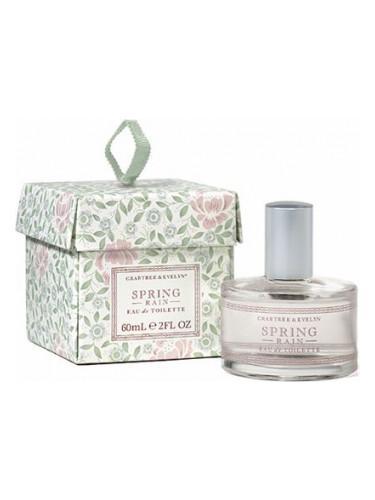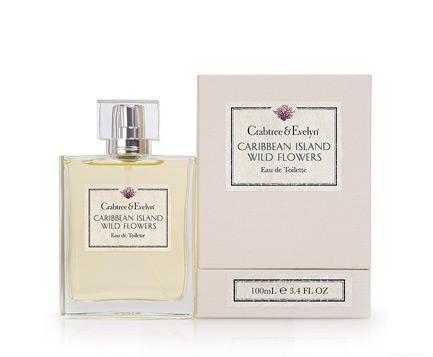The first image is the image on the left, the second image is the image on the right. For the images shown, is this caption "In the image to the right, the fragrance bottle is a different color than its box." true? Answer yes or no. Yes. The first image is the image on the left, the second image is the image on the right. For the images shown, is this caption "there are two perfume bottles in the image pair" true? Answer yes or no. Yes. 